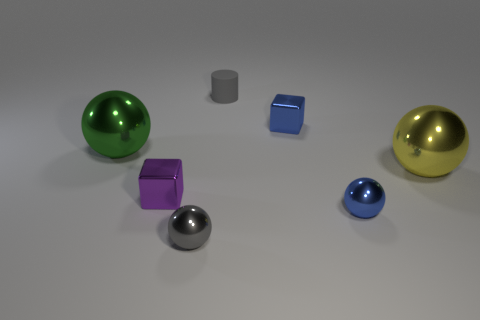Add 2 blue metallic spheres. How many objects exist? 9 Subtract all cylinders. How many objects are left? 6 Add 6 gray things. How many gray things exist? 8 Subtract 1 green spheres. How many objects are left? 6 Subtract all small gray metallic balls. Subtract all tiny brown metal objects. How many objects are left? 6 Add 4 small blocks. How many small blocks are left? 6 